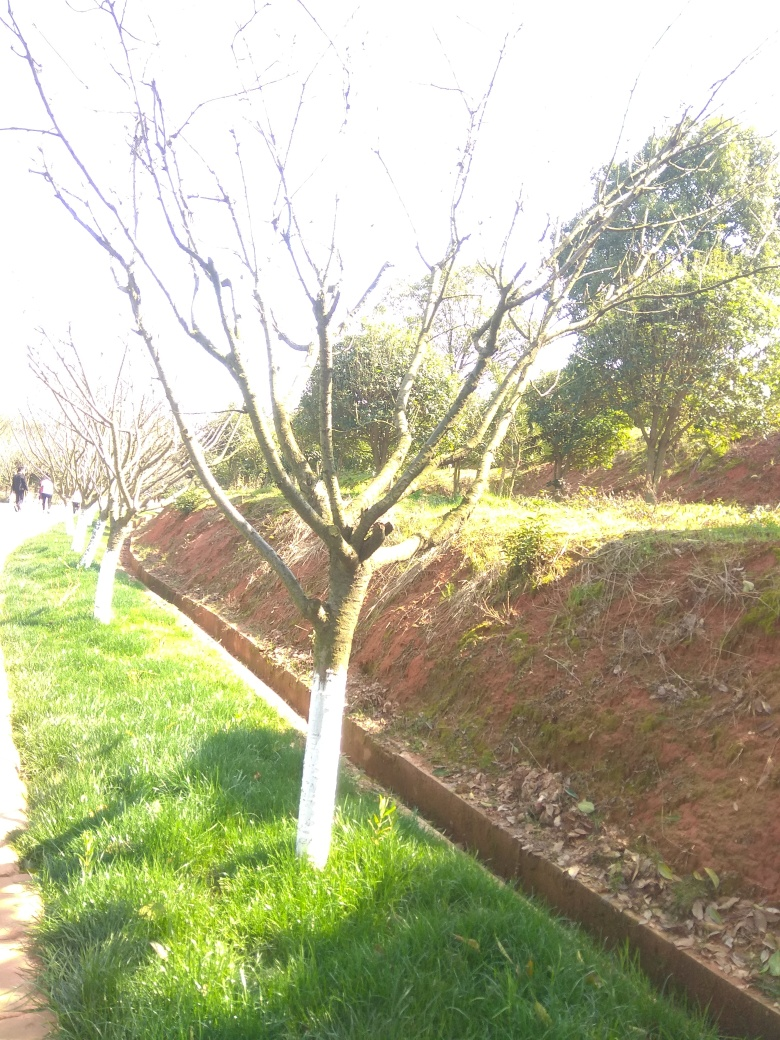What potential does this location have for different types of photography? This location has potential for various types of photography including nature photography, specifically during different seasons, as the trees could provide striking images when they blossom or change color. Additionally, with proper framing, this can be an ideal spot for portrait photography by using the natural environment as an interesting and dynamic background. 